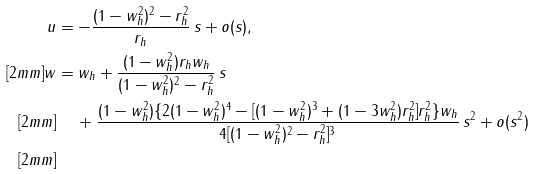<formula> <loc_0><loc_0><loc_500><loc_500>u & = - \frac { ( 1 - w _ { h } ^ { 2 } ) ^ { 2 } - r _ { h } ^ { 2 } } { r _ { h } } \, s + o ( s ) , \\ [ 2 m m ] w & = w _ { h } + \frac { ( 1 - w _ { h } ^ { 2 } ) r _ { h } w _ { h } } { ( 1 - w _ { h } ^ { 2 } ) ^ { 2 } - r _ { h } ^ { 2 } } \, s \\ [ 2 m m ] & \quad \, + \frac { ( 1 - w _ { h } ^ { 2 } ) \{ 2 ( 1 - w _ { h } ^ { 2 } ) ^ { 4 } - [ ( 1 - w _ { h } ^ { 2 } ) ^ { 3 } + ( 1 - 3 w _ { h } ^ { 2 } ) r _ { h } ^ { 2 } ] r _ { h } ^ { 2 } \} w _ { h } } { 4 [ ( 1 - w _ { h } ^ { 2 } ) ^ { 2 } - r _ { h } ^ { 2 } ] ^ { 3 } } \, s ^ { 2 } + o ( s ^ { 2 } ) \\ [ 2 m m ]</formula> 